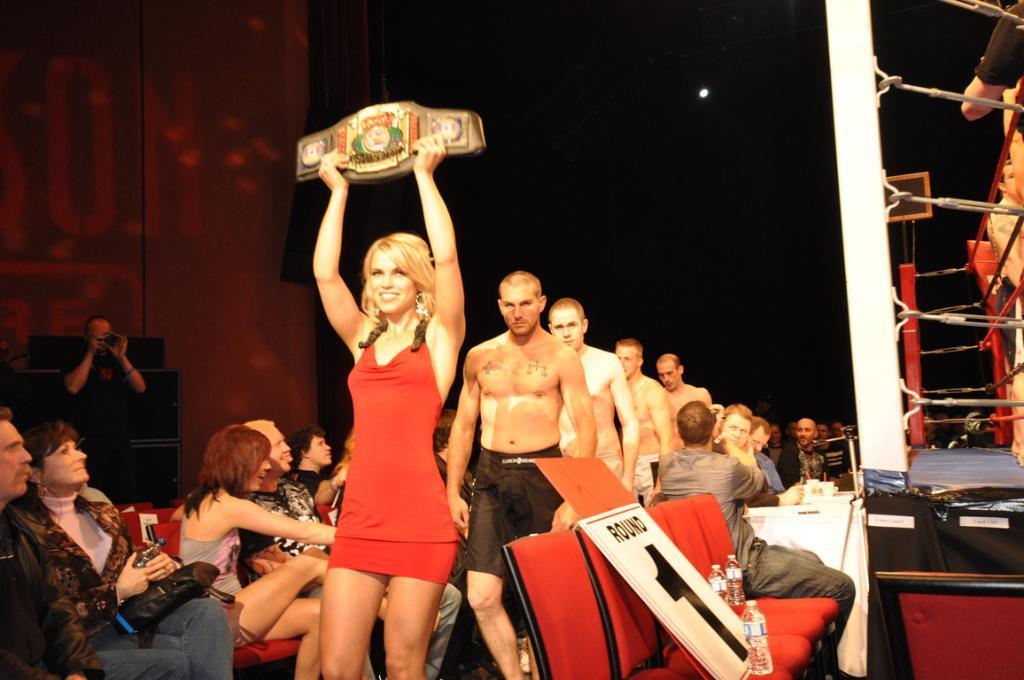Describe this image in one or two sentences. In the center of the image there is a woman smiling and holding an object and behind the woman there are four men. Image also consists of few people sitting on the chairs. On the left there are sound boxes and also a man holding a camera and on the right there is stage and also white pole. Image also consists of water bottle and there is a round one board present in this image. In the background there is black curtain. 